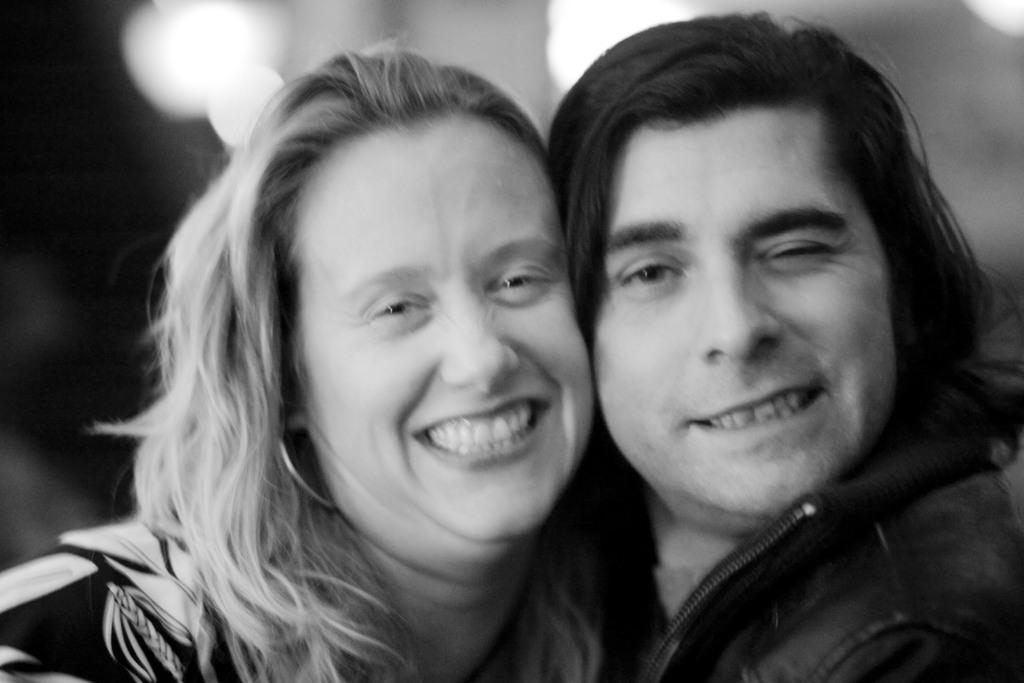Who are the people in the image? There is a man and a woman in the image. What expressions do the man and woman have in the image? Both the man and the woman are smiling in the image. Can you describe the background of the image? The background of the image is blurry. What type of cattle can be seen grazing in the background of the image? There is no cattle present in the image; the background is blurry. How does the wind affect the man and woman in the image? There is no mention of wind in the image, and the man and woman are not affected by any wind. 